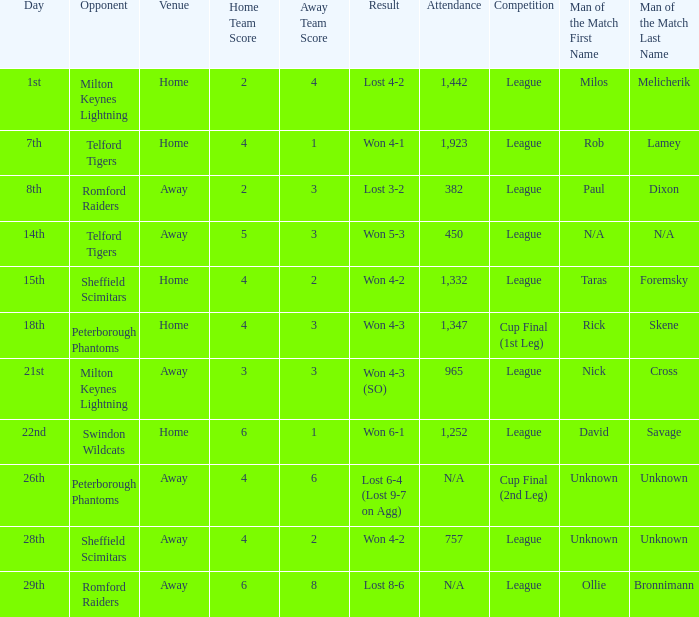What was the date when the attendance was n/a and the Man of the Match was unknown? 26th. 